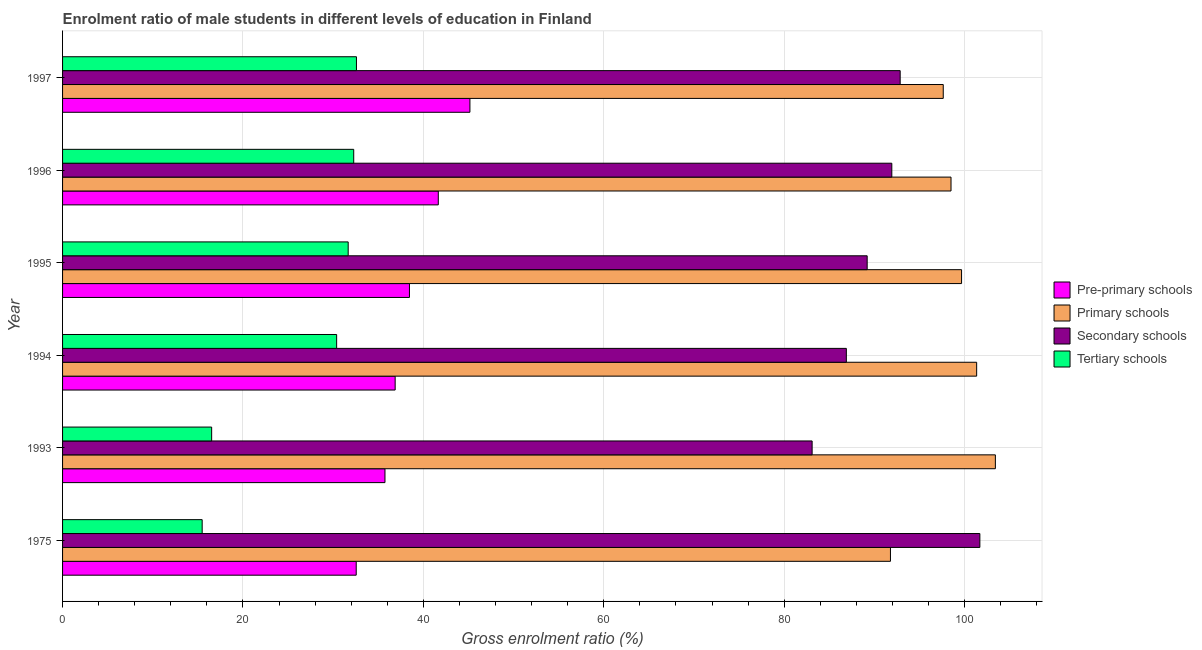How many bars are there on the 2nd tick from the top?
Your answer should be very brief. 4. What is the gross enrolment ratio(female) in tertiary schools in 1994?
Ensure brevity in your answer.  30.38. Across all years, what is the maximum gross enrolment ratio(female) in pre-primary schools?
Provide a short and direct response. 45.16. Across all years, what is the minimum gross enrolment ratio(female) in primary schools?
Keep it short and to the point. 91.78. In which year was the gross enrolment ratio(female) in secondary schools maximum?
Give a very brief answer. 1975. In which year was the gross enrolment ratio(female) in primary schools minimum?
Your response must be concise. 1975. What is the total gross enrolment ratio(female) in secondary schools in the graph?
Your response must be concise. 545.68. What is the difference between the gross enrolment ratio(female) in pre-primary schools in 1993 and that in 1997?
Your answer should be compact. -9.42. What is the difference between the gross enrolment ratio(female) in primary schools in 1993 and the gross enrolment ratio(female) in pre-primary schools in 1975?
Offer a very short reply. 70.86. What is the average gross enrolment ratio(female) in tertiary schools per year?
Provide a short and direct response. 26.49. In the year 1997, what is the difference between the gross enrolment ratio(female) in secondary schools and gross enrolment ratio(female) in tertiary schools?
Provide a short and direct response. 60.28. In how many years, is the gross enrolment ratio(female) in pre-primary schools greater than 60 %?
Your answer should be very brief. 0. What is the ratio of the gross enrolment ratio(female) in pre-primary schools in 1993 to that in 1996?
Provide a short and direct response. 0.86. Is the gross enrolment ratio(female) in secondary schools in 1975 less than that in 1994?
Ensure brevity in your answer.  No. Is the difference between the gross enrolment ratio(female) in pre-primary schools in 1993 and 1994 greater than the difference between the gross enrolment ratio(female) in secondary schools in 1993 and 1994?
Provide a short and direct response. Yes. What is the difference between the highest and the second highest gross enrolment ratio(female) in pre-primary schools?
Give a very brief answer. 3.51. What is the difference between the highest and the lowest gross enrolment ratio(female) in pre-primary schools?
Keep it short and to the point. 12.61. In how many years, is the gross enrolment ratio(female) in primary schools greater than the average gross enrolment ratio(female) in primary schools taken over all years?
Keep it short and to the point. 3. What does the 4th bar from the top in 1993 represents?
Give a very brief answer. Pre-primary schools. What does the 1st bar from the bottom in 1996 represents?
Offer a terse response. Pre-primary schools. How many years are there in the graph?
Your answer should be compact. 6. What is the difference between two consecutive major ticks on the X-axis?
Your response must be concise. 20. Are the values on the major ticks of X-axis written in scientific E-notation?
Provide a succinct answer. No. How many legend labels are there?
Provide a succinct answer. 4. What is the title of the graph?
Your answer should be compact. Enrolment ratio of male students in different levels of education in Finland. What is the label or title of the Y-axis?
Keep it short and to the point. Year. What is the Gross enrolment ratio (%) of Pre-primary schools in 1975?
Offer a terse response. 32.56. What is the Gross enrolment ratio (%) of Primary schools in 1975?
Keep it short and to the point. 91.78. What is the Gross enrolment ratio (%) in Secondary schools in 1975?
Keep it short and to the point. 101.69. What is the Gross enrolment ratio (%) of Tertiary schools in 1975?
Give a very brief answer. 15.48. What is the Gross enrolment ratio (%) in Pre-primary schools in 1993?
Ensure brevity in your answer.  35.74. What is the Gross enrolment ratio (%) in Primary schools in 1993?
Offer a very short reply. 103.41. What is the Gross enrolment ratio (%) of Secondary schools in 1993?
Make the answer very short. 83.1. What is the Gross enrolment ratio (%) in Tertiary schools in 1993?
Make the answer very short. 16.53. What is the Gross enrolment ratio (%) in Pre-primary schools in 1994?
Make the answer very short. 36.87. What is the Gross enrolment ratio (%) of Primary schools in 1994?
Keep it short and to the point. 101.34. What is the Gross enrolment ratio (%) in Secondary schools in 1994?
Your answer should be very brief. 86.89. What is the Gross enrolment ratio (%) of Tertiary schools in 1994?
Provide a succinct answer. 30.38. What is the Gross enrolment ratio (%) in Pre-primary schools in 1995?
Provide a succinct answer. 38.46. What is the Gross enrolment ratio (%) in Primary schools in 1995?
Your answer should be compact. 99.67. What is the Gross enrolment ratio (%) of Secondary schools in 1995?
Keep it short and to the point. 89.2. What is the Gross enrolment ratio (%) of Tertiary schools in 1995?
Give a very brief answer. 31.66. What is the Gross enrolment ratio (%) of Pre-primary schools in 1996?
Ensure brevity in your answer.  41.65. What is the Gross enrolment ratio (%) in Primary schools in 1996?
Your response must be concise. 98.5. What is the Gross enrolment ratio (%) in Secondary schools in 1996?
Offer a terse response. 91.93. What is the Gross enrolment ratio (%) of Tertiary schools in 1996?
Your response must be concise. 32.28. What is the Gross enrolment ratio (%) in Pre-primary schools in 1997?
Provide a succinct answer. 45.16. What is the Gross enrolment ratio (%) of Primary schools in 1997?
Your response must be concise. 97.63. What is the Gross enrolment ratio (%) of Secondary schools in 1997?
Offer a very short reply. 92.86. What is the Gross enrolment ratio (%) of Tertiary schools in 1997?
Give a very brief answer. 32.58. Across all years, what is the maximum Gross enrolment ratio (%) of Pre-primary schools?
Your answer should be compact. 45.16. Across all years, what is the maximum Gross enrolment ratio (%) of Primary schools?
Your answer should be compact. 103.41. Across all years, what is the maximum Gross enrolment ratio (%) of Secondary schools?
Make the answer very short. 101.69. Across all years, what is the maximum Gross enrolment ratio (%) of Tertiary schools?
Provide a short and direct response. 32.58. Across all years, what is the minimum Gross enrolment ratio (%) of Pre-primary schools?
Offer a very short reply. 32.56. Across all years, what is the minimum Gross enrolment ratio (%) of Primary schools?
Your response must be concise. 91.78. Across all years, what is the minimum Gross enrolment ratio (%) of Secondary schools?
Keep it short and to the point. 83.1. Across all years, what is the minimum Gross enrolment ratio (%) of Tertiary schools?
Keep it short and to the point. 15.48. What is the total Gross enrolment ratio (%) in Pre-primary schools in the graph?
Offer a very short reply. 230.44. What is the total Gross enrolment ratio (%) of Primary schools in the graph?
Offer a very short reply. 592.33. What is the total Gross enrolment ratio (%) of Secondary schools in the graph?
Your answer should be very brief. 545.68. What is the total Gross enrolment ratio (%) in Tertiary schools in the graph?
Your answer should be compact. 158.91. What is the difference between the Gross enrolment ratio (%) of Pre-primary schools in 1975 and that in 1993?
Your answer should be compact. -3.19. What is the difference between the Gross enrolment ratio (%) of Primary schools in 1975 and that in 1993?
Your answer should be very brief. -11.63. What is the difference between the Gross enrolment ratio (%) of Secondary schools in 1975 and that in 1993?
Provide a short and direct response. 18.59. What is the difference between the Gross enrolment ratio (%) of Tertiary schools in 1975 and that in 1993?
Make the answer very short. -1.05. What is the difference between the Gross enrolment ratio (%) of Pre-primary schools in 1975 and that in 1994?
Your answer should be very brief. -4.32. What is the difference between the Gross enrolment ratio (%) in Primary schools in 1975 and that in 1994?
Your response must be concise. -9.56. What is the difference between the Gross enrolment ratio (%) of Secondary schools in 1975 and that in 1994?
Ensure brevity in your answer.  14.8. What is the difference between the Gross enrolment ratio (%) in Tertiary schools in 1975 and that in 1994?
Make the answer very short. -14.91. What is the difference between the Gross enrolment ratio (%) of Pre-primary schools in 1975 and that in 1995?
Your answer should be very brief. -5.9. What is the difference between the Gross enrolment ratio (%) in Primary schools in 1975 and that in 1995?
Offer a very short reply. -7.88. What is the difference between the Gross enrolment ratio (%) of Secondary schools in 1975 and that in 1995?
Ensure brevity in your answer.  12.49. What is the difference between the Gross enrolment ratio (%) in Tertiary schools in 1975 and that in 1995?
Ensure brevity in your answer.  -16.19. What is the difference between the Gross enrolment ratio (%) of Pre-primary schools in 1975 and that in 1996?
Ensure brevity in your answer.  -9.1. What is the difference between the Gross enrolment ratio (%) in Primary schools in 1975 and that in 1996?
Ensure brevity in your answer.  -6.71. What is the difference between the Gross enrolment ratio (%) in Secondary schools in 1975 and that in 1996?
Keep it short and to the point. 9.76. What is the difference between the Gross enrolment ratio (%) of Tertiary schools in 1975 and that in 1996?
Give a very brief answer. -16.8. What is the difference between the Gross enrolment ratio (%) in Pre-primary schools in 1975 and that in 1997?
Provide a short and direct response. -12.61. What is the difference between the Gross enrolment ratio (%) in Primary schools in 1975 and that in 1997?
Provide a short and direct response. -5.85. What is the difference between the Gross enrolment ratio (%) of Secondary schools in 1975 and that in 1997?
Provide a succinct answer. 8.83. What is the difference between the Gross enrolment ratio (%) of Tertiary schools in 1975 and that in 1997?
Offer a terse response. -17.1. What is the difference between the Gross enrolment ratio (%) in Pre-primary schools in 1993 and that in 1994?
Keep it short and to the point. -1.13. What is the difference between the Gross enrolment ratio (%) in Primary schools in 1993 and that in 1994?
Ensure brevity in your answer.  2.08. What is the difference between the Gross enrolment ratio (%) in Secondary schools in 1993 and that in 1994?
Make the answer very short. -3.79. What is the difference between the Gross enrolment ratio (%) of Tertiary schools in 1993 and that in 1994?
Offer a terse response. -13.86. What is the difference between the Gross enrolment ratio (%) in Pre-primary schools in 1993 and that in 1995?
Your response must be concise. -2.71. What is the difference between the Gross enrolment ratio (%) in Primary schools in 1993 and that in 1995?
Offer a terse response. 3.75. What is the difference between the Gross enrolment ratio (%) in Secondary schools in 1993 and that in 1995?
Keep it short and to the point. -6.1. What is the difference between the Gross enrolment ratio (%) in Tertiary schools in 1993 and that in 1995?
Offer a very short reply. -15.14. What is the difference between the Gross enrolment ratio (%) of Pre-primary schools in 1993 and that in 1996?
Your response must be concise. -5.91. What is the difference between the Gross enrolment ratio (%) in Primary schools in 1993 and that in 1996?
Your answer should be very brief. 4.92. What is the difference between the Gross enrolment ratio (%) of Secondary schools in 1993 and that in 1996?
Offer a very short reply. -8.83. What is the difference between the Gross enrolment ratio (%) of Tertiary schools in 1993 and that in 1996?
Offer a very short reply. -15.75. What is the difference between the Gross enrolment ratio (%) of Pre-primary schools in 1993 and that in 1997?
Your answer should be very brief. -9.42. What is the difference between the Gross enrolment ratio (%) of Primary schools in 1993 and that in 1997?
Provide a succinct answer. 5.78. What is the difference between the Gross enrolment ratio (%) in Secondary schools in 1993 and that in 1997?
Provide a short and direct response. -9.76. What is the difference between the Gross enrolment ratio (%) of Tertiary schools in 1993 and that in 1997?
Your response must be concise. -16.05. What is the difference between the Gross enrolment ratio (%) in Pre-primary schools in 1994 and that in 1995?
Your response must be concise. -1.59. What is the difference between the Gross enrolment ratio (%) in Primary schools in 1994 and that in 1995?
Make the answer very short. 1.67. What is the difference between the Gross enrolment ratio (%) in Secondary schools in 1994 and that in 1995?
Provide a short and direct response. -2.31. What is the difference between the Gross enrolment ratio (%) of Tertiary schools in 1994 and that in 1995?
Your answer should be very brief. -1.28. What is the difference between the Gross enrolment ratio (%) in Pre-primary schools in 1994 and that in 1996?
Offer a very short reply. -4.78. What is the difference between the Gross enrolment ratio (%) of Primary schools in 1994 and that in 1996?
Give a very brief answer. 2.84. What is the difference between the Gross enrolment ratio (%) of Secondary schools in 1994 and that in 1996?
Ensure brevity in your answer.  -5.04. What is the difference between the Gross enrolment ratio (%) of Tertiary schools in 1994 and that in 1996?
Provide a short and direct response. -1.89. What is the difference between the Gross enrolment ratio (%) in Pre-primary schools in 1994 and that in 1997?
Offer a terse response. -8.29. What is the difference between the Gross enrolment ratio (%) in Primary schools in 1994 and that in 1997?
Your answer should be very brief. 3.7. What is the difference between the Gross enrolment ratio (%) of Secondary schools in 1994 and that in 1997?
Offer a very short reply. -5.97. What is the difference between the Gross enrolment ratio (%) in Tertiary schools in 1994 and that in 1997?
Your answer should be very brief. -2.2. What is the difference between the Gross enrolment ratio (%) in Pre-primary schools in 1995 and that in 1996?
Provide a short and direct response. -3.2. What is the difference between the Gross enrolment ratio (%) of Primary schools in 1995 and that in 1996?
Keep it short and to the point. 1.17. What is the difference between the Gross enrolment ratio (%) of Secondary schools in 1995 and that in 1996?
Your answer should be very brief. -2.73. What is the difference between the Gross enrolment ratio (%) in Tertiary schools in 1995 and that in 1996?
Ensure brevity in your answer.  -0.61. What is the difference between the Gross enrolment ratio (%) of Pre-primary schools in 1995 and that in 1997?
Ensure brevity in your answer.  -6.7. What is the difference between the Gross enrolment ratio (%) in Primary schools in 1995 and that in 1997?
Your answer should be compact. 2.03. What is the difference between the Gross enrolment ratio (%) in Secondary schools in 1995 and that in 1997?
Provide a short and direct response. -3.66. What is the difference between the Gross enrolment ratio (%) of Tertiary schools in 1995 and that in 1997?
Keep it short and to the point. -0.92. What is the difference between the Gross enrolment ratio (%) of Pre-primary schools in 1996 and that in 1997?
Make the answer very short. -3.51. What is the difference between the Gross enrolment ratio (%) in Primary schools in 1996 and that in 1997?
Give a very brief answer. 0.86. What is the difference between the Gross enrolment ratio (%) of Secondary schools in 1996 and that in 1997?
Your response must be concise. -0.93. What is the difference between the Gross enrolment ratio (%) of Tertiary schools in 1996 and that in 1997?
Offer a terse response. -0.3. What is the difference between the Gross enrolment ratio (%) of Pre-primary schools in 1975 and the Gross enrolment ratio (%) of Primary schools in 1993?
Provide a succinct answer. -70.86. What is the difference between the Gross enrolment ratio (%) of Pre-primary schools in 1975 and the Gross enrolment ratio (%) of Secondary schools in 1993?
Keep it short and to the point. -50.54. What is the difference between the Gross enrolment ratio (%) of Pre-primary schools in 1975 and the Gross enrolment ratio (%) of Tertiary schools in 1993?
Your answer should be compact. 16.03. What is the difference between the Gross enrolment ratio (%) of Primary schools in 1975 and the Gross enrolment ratio (%) of Secondary schools in 1993?
Provide a short and direct response. 8.68. What is the difference between the Gross enrolment ratio (%) of Primary schools in 1975 and the Gross enrolment ratio (%) of Tertiary schools in 1993?
Keep it short and to the point. 75.25. What is the difference between the Gross enrolment ratio (%) of Secondary schools in 1975 and the Gross enrolment ratio (%) of Tertiary schools in 1993?
Give a very brief answer. 85.16. What is the difference between the Gross enrolment ratio (%) in Pre-primary schools in 1975 and the Gross enrolment ratio (%) in Primary schools in 1994?
Provide a short and direct response. -68.78. What is the difference between the Gross enrolment ratio (%) of Pre-primary schools in 1975 and the Gross enrolment ratio (%) of Secondary schools in 1994?
Offer a very short reply. -54.34. What is the difference between the Gross enrolment ratio (%) of Pre-primary schools in 1975 and the Gross enrolment ratio (%) of Tertiary schools in 1994?
Offer a terse response. 2.17. What is the difference between the Gross enrolment ratio (%) of Primary schools in 1975 and the Gross enrolment ratio (%) of Secondary schools in 1994?
Offer a very short reply. 4.89. What is the difference between the Gross enrolment ratio (%) in Primary schools in 1975 and the Gross enrolment ratio (%) in Tertiary schools in 1994?
Keep it short and to the point. 61.4. What is the difference between the Gross enrolment ratio (%) in Secondary schools in 1975 and the Gross enrolment ratio (%) in Tertiary schools in 1994?
Provide a succinct answer. 71.31. What is the difference between the Gross enrolment ratio (%) of Pre-primary schools in 1975 and the Gross enrolment ratio (%) of Primary schools in 1995?
Provide a succinct answer. -67.11. What is the difference between the Gross enrolment ratio (%) in Pre-primary schools in 1975 and the Gross enrolment ratio (%) in Secondary schools in 1995?
Your answer should be very brief. -56.64. What is the difference between the Gross enrolment ratio (%) in Pre-primary schools in 1975 and the Gross enrolment ratio (%) in Tertiary schools in 1995?
Ensure brevity in your answer.  0.89. What is the difference between the Gross enrolment ratio (%) of Primary schools in 1975 and the Gross enrolment ratio (%) of Secondary schools in 1995?
Make the answer very short. 2.58. What is the difference between the Gross enrolment ratio (%) of Primary schools in 1975 and the Gross enrolment ratio (%) of Tertiary schools in 1995?
Provide a short and direct response. 60.12. What is the difference between the Gross enrolment ratio (%) in Secondary schools in 1975 and the Gross enrolment ratio (%) in Tertiary schools in 1995?
Provide a short and direct response. 70.03. What is the difference between the Gross enrolment ratio (%) of Pre-primary schools in 1975 and the Gross enrolment ratio (%) of Primary schools in 1996?
Your answer should be compact. -65.94. What is the difference between the Gross enrolment ratio (%) of Pre-primary schools in 1975 and the Gross enrolment ratio (%) of Secondary schools in 1996?
Provide a short and direct response. -59.38. What is the difference between the Gross enrolment ratio (%) in Pre-primary schools in 1975 and the Gross enrolment ratio (%) in Tertiary schools in 1996?
Your response must be concise. 0.28. What is the difference between the Gross enrolment ratio (%) of Primary schools in 1975 and the Gross enrolment ratio (%) of Secondary schools in 1996?
Your answer should be very brief. -0.15. What is the difference between the Gross enrolment ratio (%) of Primary schools in 1975 and the Gross enrolment ratio (%) of Tertiary schools in 1996?
Provide a short and direct response. 59.5. What is the difference between the Gross enrolment ratio (%) in Secondary schools in 1975 and the Gross enrolment ratio (%) in Tertiary schools in 1996?
Make the answer very short. 69.41. What is the difference between the Gross enrolment ratio (%) in Pre-primary schools in 1975 and the Gross enrolment ratio (%) in Primary schools in 1997?
Offer a very short reply. -65.08. What is the difference between the Gross enrolment ratio (%) in Pre-primary schools in 1975 and the Gross enrolment ratio (%) in Secondary schools in 1997?
Give a very brief answer. -60.3. What is the difference between the Gross enrolment ratio (%) in Pre-primary schools in 1975 and the Gross enrolment ratio (%) in Tertiary schools in 1997?
Offer a terse response. -0.03. What is the difference between the Gross enrolment ratio (%) of Primary schools in 1975 and the Gross enrolment ratio (%) of Secondary schools in 1997?
Provide a succinct answer. -1.08. What is the difference between the Gross enrolment ratio (%) in Primary schools in 1975 and the Gross enrolment ratio (%) in Tertiary schools in 1997?
Make the answer very short. 59.2. What is the difference between the Gross enrolment ratio (%) in Secondary schools in 1975 and the Gross enrolment ratio (%) in Tertiary schools in 1997?
Offer a terse response. 69.11. What is the difference between the Gross enrolment ratio (%) of Pre-primary schools in 1993 and the Gross enrolment ratio (%) of Primary schools in 1994?
Give a very brief answer. -65.6. What is the difference between the Gross enrolment ratio (%) of Pre-primary schools in 1993 and the Gross enrolment ratio (%) of Secondary schools in 1994?
Provide a short and direct response. -51.15. What is the difference between the Gross enrolment ratio (%) of Pre-primary schools in 1993 and the Gross enrolment ratio (%) of Tertiary schools in 1994?
Keep it short and to the point. 5.36. What is the difference between the Gross enrolment ratio (%) in Primary schools in 1993 and the Gross enrolment ratio (%) in Secondary schools in 1994?
Offer a very short reply. 16.52. What is the difference between the Gross enrolment ratio (%) of Primary schools in 1993 and the Gross enrolment ratio (%) of Tertiary schools in 1994?
Provide a short and direct response. 73.03. What is the difference between the Gross enrolment ratio (%) of Secondary schools in 1993 and the Gross enrolment ratio (%) of Tertiary schools in 1994?
Make the answer very short. 52.71. What is the difference between the Gross enrolment ratio (%) of Pre-primary schools in 1993 and the Gross enrolment ratio (%) of Primary schools in 1995?
Provide a short and direct response. -63.92. What is the difference between the Gross enrolment ratio (%) of Pre-primary schools in 1993 and the Gross enrolment ratio (%) of Secondary schools in 1995?
Provide a succinct answer. -53.46. What is the difference between the Gross enrolment ratio (%) in Pre-primary schools in 1993 and the Gross enrolment ratio (%) in Tertiary schools in 1995?
Ensure brevity in your answer.  4.08. What is the difference between the Gross enrolment ratio (%) of Primary schools in 1993 and the Gross enrolment ratio (%) of Secondary schools in 1995?
Ensure brevity in your answer.  14.21. What is the difference between the Gross enrolment ratio (%) of Primary schools in 1993 and the Gross enrolment ratio (%) of Tertiary schools in 1995?
Your answer should be very brief. 71.75. What is the difference between the Gross enrolment ratio (%) in Secondary schools in 1993 and the Gross enrolment ratio (%) in Tertiary schools in 1995?
Provide a succinct answer. 51.43. What is the difference between the Gross enrolment ratio (%) in Pre-primary schools in 1993 and the Gross enrolment ratio (%) in Primary schools in 1996?
Your answer should be compact. -62.75. What is the difference between the Gross enrolment ratio (%) in Pre-primary schools in 1993 and the Gross enrolment ratio (%) in Secondary schools in 1996?
Your answer should be compact. -56.19. What is the difference between the Gross enrolment ratio (%) in Pre-primary schools in 1993 and the Gross enrolment ratio (%) in Tertiary schools in 1996?
Offer a very short reply. 3.46. What is the difference between the Gross enrolment ratio (%) in Primary schools in 1993 and the Gross enrolment ratio (%) in Secondary schools in 1996?
Keep it short and to the point. 11.48. What is the difference between the Gross enrolment ratio (%) of Primary schools in 1993 and the Gross enrolment ratio (%) of Tertiary schools in 1996?
Offer a very short reply. 71.14. What is the difference between the Gross enrolment ratio (%) of Secondary schools in 1993 and the Gross enrolment ratio (%) of Tertiary schools in 1996?
Offer a terse response. 50.82. What is the difference between the Gross enrolment ratio (%) in Pre-primary schools in 1993 and the Gross enrolment ratio (%) in Primary schools in 1997?
Make the answer very short. -61.89. What is the difference between the Gross enrolment ratio (%) of Pre-primary schools in 1993 and the Gross enrolment ratio (%) of Secondary schools in 1997?
Provide a short and direct response. -57.12. What is the difference between the Gross enrolment ratio (%) in Pre-primary schools in 1993 and the Gross enrolment ratio (%) in Tertiary schools in 1997?
Provide a short and direct response. 3.16. What is the difference between the Gross enrolment ratio (%) in Primary schools in 1993 and the Gross enrolment ratio (%) in Secondary schools in 1997?
Provide a succinct answer. 10.55. What is the difference between the Gross enrolment ratio (%) in Primary schools in 1993 and the Gross enrolment ratio (%) in Tertiary schools in 1997?
Your answer should be compact. 70.83. What is the difference between the Gross enrolment ratio (%) in Secondary schools in 1993 and the Gross enrolment ratio (%) in Tertiary schools in 1997?
Make the answer very short. 50.52. What is the difference between the Gross enrolment ratio (%) in Pre-primary schools in 1994 and the Gross enrolment ratio (%) in Primary schools in 1995?
Give a very brief answer. -62.79. What is the difference between the Gross enrolment ratio (%) in Pre-primary schools in 1994 and the Gross enrolment ratio (%) in Secondary schools in 1995?
Your answer should be compact. -52.33. What is the difference between the Gross enrolment ratio (%) of Pre-primary schools in 1994 and the Gross enrolment ratio (%) of Tertiary schools in 1995?
Provide a succinct answer. 5.21. What is the difference between the Gross enrolment ratio (%) in Primary schools in 1994 and the Gross enrolment ratio (%) in Secondary schools in 1995?
Provide a succinct answer. 12.14. What is the difference between the Gross enrolment ratio (%) in Primary schools in 1994 and the Gross enrolment ratio (%) in Tertiary schools in 1995?
Ensure brevity in your answer.  69.67. What is the difference between the Gross enrolment ratio (%) of Secondary schools in 1994 and the Gross enrolment ratio (%) of Tertiary schools in 1995?
Make the answer very short. 55.23. What is the difference between the Gross enrolment ratio (%) of Pre-primary schools in 1994 and the Gross enrolment ratio (%) of Primary schools in 1996?
Ensure brevity in your answer.  -61.62. What is the difference between the Gross enrolment ratio (%) of Pre-primary schools in 1994 and the Gross enrolment ratio (%) of Secondary schools in 1996?
Your response must be concise. -55.06. What is the difference between the Gross enrolment ratio (%) in Pre-primary schools in 1994 and the Gross enrolment ratio (%) in Tertiary schools in 1996?
Offer a terse response. 4.59. What is the difference between the Gross enrolment ratio (%) of Primary schools in 1994 and the Gross enrolment ratio (%) of Secondary schools in 1996?
Offer a terse response. 9.41. What is the difference between the Gross enrolment ratio (%) of Primary schools in 1994 and the Gross enrolment ratio (%) of Tertiary schools in 1996?
Keep it short and to the point. 69.06. What is the difference between the Gross enrolment ratio (%) in Secondary schools in 1994 and the Gross enrolment ratio (%) in Tertiary schools in 1996?
Ensure brevity in your answer.  54.61. What is the difference between the Gross enrolment ratio (%) of Pre-primary schools in 1994 and the Gross enrolment ratio (%) of Primary schools in 1997?
Offer a very short reply. -60.76. What is the difference between the Gross enrolment ratio (%) of Pre-primary schools in 1994 and the Gross enrolment ratio (%) of Secondary schools in 1997?
Your response must be concise. -55.99. What is the difference between the Gross enrolment ratio (%) in Pre-primary schools in 1994 and the Gross enrolment ratio (%) in Tertiary schools in 1997?
Offer a terse response. 4.29. What is the difference between the Gross enrolment ratio (%) in Primary schools in 1994 and the Gross enrolment ratio (%) in Secondary schools in 1997?
Your answer should be compact. 8.48. What is the difference between the Gross enrolment ratio (%) of Primary schools in 1994 and the Gross enrolment ratio (%) of Tertiary schools in 1997?
Ensure brevity in your answer.  68.76. What is the difference between the Gross enrolment ratio (%) in Secondary schools in 1994 and the Gross enrolment ratio (%) in Tertiary schools in 1997?
Make the answer very short. 54.31. What is the difference between the Gross enrolment ratio (%) in Pre-primary schools in 1995 and the Gross enrolment ratio (%) in Primary schools in 1996?
Keep it short and to the point. -60.04. What is the difference between the Gross enrolment ratio (%) in Pre-primary schools in 1995 and the Gross enrolment ratio (%) in Secondary schools in 1996?
Make the answer very short. -53.48. What is the difference between the Gross enrolment ratio (%) of Pre-primary schools in 1995 and the Gross enrolment ratio (%) of Tertiary schools in 1996?
Provide a succinct answer. 6.18. What is the difference between the Gross enrolment ratio (%) of Primary schools in 1995 and the Gross enrolment ratio (%) of Secondary schools in 1996?
Give a very brief answer. 7.73. What is the difference between the Gross enrolment ratio (%) of Primary schools in 1995 and the Gross enrolment ratio (%) of Tertiary schools in 1996?
Give a very brief answer. 67.39. What is the difference between the Gross enrolment ratio (%) in Secondary schools in 1995 and the Gross enrolment ratio (%) in Tertiary schools in 1996?
Provide a short and direct response. 56.92. What is the difference between the Gross enrolment ratio (%) of Pre-primary schools in 1995 and the Gross enrolment ratio (%) of Primary schools in 1997?
Your answer should be compact. -59.18. What is the difference between the Gross enrolment ratio (%) of Pre-primary schools in 1995 and the Gross enrolment ratio (%) of Secondary schools in 1997?
Your answer should be compact. -54.4. What is the difference between the Gross enrolment ratio (%) in Pre-primary schools in 1995 and the Gross enrolment ratio (%) in Tertiary schools in 1997?
Your answer should be compact. 5.88. What is the difference between the Gross enrolment ratio (%) of Primary schools in 1995 and the Gross enrolment ratio (%) of Secondary schools in 1997?
Your response must be concise. 6.81. What is the difference between the Gross enrolment ratio (%) of Primary schools in 1995 and the Gross enrolment ratio (%) of Tertiary schools in 1997?
Give a very brief answer. 67.08. What is the difference between the Gross enrolment ratio (%) in Secondary schools in 1995 and the Gross enrolment ratio (%) in Tertiary schools in 1997?
Offer a very short reply. 56.62. What is the difference between the Gross enrolment ratio (%) of Pre-primary schools in 1996 and the Gross enrolment ratio (%) of Primary schools in 1997?
Your response must be concise. -55.98. What is the difference between the Gross enrolment ratio (%) of Pre-primary schools in 1996 and the Gross enrolment ratio (%) of Secondary schools in 1997?
Your response must be concise. -51.21. What is the difference between the Gross enrolment ratio (%) in Pre-primary schools in 1996 and the Gross enrolment ratio (%) in Tertiary schools in 1997?
Offer a very short reply. 9.07. What is the difference between the Gross enrolment ratio (%) of Primary schools in 1996 and the Gross enrolment ratio (%) of Secondary schools in 1997?
Give a very brief answer. 5.64. What is the difference between the Gross enrolment ratio (%) in Primary schools in 1996 and the Gross enrolment ratio (%) in Tertiary schools in 1997?
Your answer should be compact. 65.92. What is the difference between the Gross enrolment ratio (%) in Secondary schools in 1996 and the Gross enrolment ratio (%) in Tertiary schools in 1997?
Ensure brevity in your answer.  59.35. What is the average Gross enrolment ratio (%) of Pre-primary schools per year?
Offer a very short reply. 38.41. What is the average Gross enrolment ratio (%) in Primary schools per year?
Keep it short and to the point. 98.72. What is the average Gross enrolment ratio (%) in Secondary schools per year?
Give a very brief answer. 90.95. What is the average Gross enrolment ratio (%) in Tertiary schools per year?
Give a very brief answer. 26.49. In the year 1975, what is the difference between the Gross enrolment ratio (%) of Pre-primary schools and Gross enrolment ratio (%) of Primary schools?
Your response must be concise. -59.23. In the year 1975, what is the difference between the Gross enrolment ratio (%) in Pre-primary schools and Gross enrolment ratio (%) in Secondary schools?
Your answer should be compact. -69.14. In the year 1975, what is the difference between the Gross enrolment ratio (%) of Pre-primary schools and Gross enrolment ratio (%) of Tertiary schools?
Keep it short and to the point. 17.08. In the year 1975, what is the difference between the Gross enrolment ratio (%) of Primary schools and Gross enrolment ratio (%) of Secondary schools?
Give a very brief answer. -9.91. In the year 1975, what is the difference between the Gross enrolment ratio (%) of Primary schools and Gross enrolment ratio (%) of Tertiary schools?
Provide a succinct answer. 76.3. In the year 1975, what is the difference between the Gross enrolment ratio (%) in Secondary schools and Gross enrolment ratio (%) in Tertiary schools?
Provide a succinct answer. 86.22. In the year 1993, what is the difference between the Gross enrolment ratio (%) in Pre-primary schools and Gross enrolment ratio (%) in Primary schools?
Your answer should be compact. -67.67. In the year 1993, what is the difference between the Gross enrolment ratio (%) of Pre-primary schools and Gross enrolment ratio (%) of Secondary schools?
Keep it short and to the point. -47.36. In the year 1993, what is the difference between the Gross enrolment ratio (%) of Pre-primary schools and Gross enrolment ratio (%) of Tertiary schools?
Give a very brief answer. 19.21. In the year 1993, what is the difference between the Gross enrolment ratio (%) in Primary schools and Gross enrolment ratio (%) in Secondary schools?
Provide a succinct answer. 20.32. In the year 1993, what is the difference between the Gross enrolment ratio (%) of Primary schools and Gross enrolment ratio (%) of Tertiary schools?
Offer a terse response. 86.89. In the year 1993, what is the difference between the Gross enrolment ratio (%) of Secondary schools and Gross enrolment ratio (%) of Tertiary schools?
Offer a terse response. 66.57. In the year 1994, what is the difference between the Gross enrolment ratio (%) in Pre-primary schools and Gross enrolment ratio (%) in Primary schools?
Give a very brief answer. -64.47. In the year 1994, what is the difference between the Gross enrolment ratio (%) in Pre-primary schools and Gross enrolment ratio (%) in Secondary schools?
Ensure brevity in your answer.  -50.02. In the year 1994, what is the difference between the Gross enrolment ratio (%) in Pre-primary schools and Gross enrolment ratio (%) in Tertiary schools?
Your response must be concise. 6.49. In the year 1994, what is the difference between the Gross enrolment ratio (%) of Primary schools and Gross enrolment ratio (%) of Secondary schools?
Your answer should be compact. 14.45. In the year 1994, what is the difference between the Gross enrolment ratio (%) in Primary schools and Gross enrolment ratio (%) in Tertiary schools?
Ensure brevity in your answer.  70.95. In the year 1994, what is the difference between the Gross enrolment ratio (%) in Secondary schools and Gross enrolment ratio (%) in Tertiary schools?
Provide a succinct answer. 56.51. In the year 1995, what is the difference between the Gross enrolment ratio (%) of Pre-primary schools and Gross enrolment ratio (%) of Primary schools?
Give a very brief answer. -61.21. In the year 1995, what is the difference between the Gross enrolment ratio (%) of Pre-primary schools and Gross enrolment ratio (%) of Secondary schools?
Your response must be concise. -50.74. In the year 1995, what is the difference between the Gross enrolment ratio (%) in Pre-primary schools and Gross enrolment ratio (%) in Tertiary schools?
Offer a very short reply. 6.79. In the year 1995, what is the difference between the Gross enrolment ratio (%) in Primary schools and Gross enrolment ratio (%) in Secondary schools?
Your answer should be compact. 10.46. In the year 1995, what is the difference between the Gross enrolment ratio (%) of Primary schools and Gross enrolment ratio (%) of Tertiary schools?
Keep it short and to the point. 68. In the year 1995, what is the difference between the Gross enrolment ratio (%) of Secondary schools and Gross enrolment ratio (%) of Tertiary schools?
Ensure brevity in your answer.  57.54. In the year 1996, what is the difference between the Gross enrolment ratio (%) of Pre-primary schools and Gross enrolment ratio (%) of Primary schools?
Give a very brief answer. -56.84. In the year 1996, what is the difference between the Gross enrolment ratio (%) in Pre-primary schools and Gross enrolment ratio (%) in Secondary schools?
Ensure brevity in your answer.  -50.28. In the year 1996, what is the difference between the Gross enrolment ratio (%) in Pre-primary schools and Gross enrolment ratio (%) in Tertiary schools?
Your response must be concise. 9.38. In the year 1996, what is the difference between the Gross enrolment ratio (%) of Primary schools and Gross enrolment ratio (%) of Secondary schools?
Your response must be concise. 6.56. In the year 1996, what is the difference between the Gross enrolment ratio (%) in Primary schools and Gross enrolment ratio (%) in Tertiary schools?
Make the answer very short. 66.22. In the year 1996, what is the difference between the Gross enrolment ratio (%) in Secondary schools and Gross enrolment ratio (%) in Tertiary schools?
Give a very brief answer. 59.65. In the year 1997, what is the difference between the Gross enrolment ratio (%) in Pre-primary schools and Gross enrolment ratio (%) in Primary schools?
Make the answer very short. -52.47. In the year 1997, what is the difference between the Gross enrolment ratio (%) of Pre-primary schools and Gross enrolment ratio (%) of Secondary schools?
Your response must be concise. -47.7. In the year 1997, what is the difference between the Gross enrolment ratio (%) in Pre-primary schools and Gross enrolment ratio (%) in Tertiary schools?
Keep it short and to the point. 12.58. In the year 1997, what is the difference between the Gross enrolment ratio (%) in Primary schools and Gross enrolment ratio (%) in Secondary schools?
Offer a very short reply. 4.77. In the year 1997, what is the difference between the Gross enrolment ratio (%) in Primary schools and Gross enrolment ratio (%) in Tertiary schools?
Provide a succinct answer. 65.05. In the year 1997, what is the difference between the Gross enrolment ratio (%) in Secondary schools and Gross enrolment ratio (%) in Tertiary schools?
Give a very brief answer. 60.28. What is the ratio of the Gross enrolment ratio (%) in Pre-primary schools in 1975 to that in 1993?
Your answer should be very brief. 0.91. What is the ratio of the Gross enrolment ratio (%) in Primary schools in 1975 to that in 1993?
Keep it short and to the point. 0.89. What is the ratio of the Gross enrolment ratio (%) of Secondary schools in 1975 to that in 1993?
Your answer should be compact. 1.22. What is the ratio of the Gross enrolment ratio (%) in Tertiary schools in 1975 to that in 1993?
Keep it short and to the point. 0.94. What is the ratio of the Gross enrolment ratio (%) of Pre-primary schools in 1975 to that in 1994?
Make the answer very short. 0.88. What is the ratio of the Gross enrolment ratio (%) of Primary schools in 1975 to that in 1994?
Offer a terse response. 0.91. What is the ratio of the Gross enrolment ratio (%) of Secondary schools in 1975 to that in 1994?
Your response must be concise. 1.17. What is the ratio of the Gross enrolment ratio (%) of Tertiary schools in 1975 to that in 1994?
Your answer should be compact. 0.51. What is the ratio of the Gross enrolment ratio (%) in Pre-primary schools in 1975 to that in 1995?
Your response must be concise. 0.85. What is the ratio of the Gross enrolment ratio (%) in Primary schools in 1975 to that in 1995?
Your answer should be very brief. 0.92. What is the ratio of the Gross enrolment ratio (%) in Secondary schools in 1975 to that in 1995?
Offer a very short reply. 1.14. What is the ratio of the Gross enrolment ratio (%) in Tertiary schools in 1975 to that in 1995?
Your response must be concise. 0.49. What is the ratio of the Gross enrolment ratio (%) in Pre-primary schools in 1975 to that in 1996?
Give a very brief answer. 0.78. What is the ratio of the Gross enrolment ratio (%) of Primary schools in 1975 to that in 1996?
Give a very brief answer. 0.93. What is the ratio of the Gross enrolment ratio (%) of Secondary schools in 1975 to that in 1996?
Provide a short and direct response. 1.11. What is the ratio of the Gross enrolment ratio (%) in Tertiary schools in 1975 to that in 1996?
Offer a terse response. 0.48. What is the ratio of the Gross enrolment ratio (%) in Pre-primary schools in 1975 to that in 1997?
Ensure brevity in your answer.  0.72. What is the ratio of the Gross enrolment ratio (%) of Primary schools in 1975 to that in 1997?
Offer a very short reply. 0.94. What is the ratio of the Gross enrolment ratio (%) in Secondary schools in 1975 to that in 1997?
Your answer should be compact. 1.1. What is the ratio of the Gross enrolment ratio (%) of Tertiary schools in 1975 to that in 1997?
Ensure brevity in your answer.  0.48. What is the ratio of the Gross enrolment ratio (%) of Pre-primary schools in 1993 to that in 1994?
Your answer should be compact. 0.97. What is the ratio of the Gross enrolment ratio (%) in Primary schools in 1993 to that in 1994?
Offer a terse response. 1.02. What is the ratio of the Gross enrolment ratio (%) in Secondary schools in 1993 to that in 1994?
Make the answer very short. 0.96. What is the ratio of the Gross enrolment ratio (%) in Tertiary schools in 1993 to that in 1994?
Provide a short and direct response. 0.54. What is the ratio of the Gross enrolment ratio (%) of Pre-primary schools in 1993 to that in 1995?
Make the answer very short. 0.93. What is the ratio of the Gross enrolment ratio (%) in Primary schools in 1993 to that in 1995?
Your response must be concise. 1.04. What is the ratio of the Gross enrolment ratio (%) of Secondary schools in 1993 to that in 1995?
Provide a short and direct response. 0.93. What is the ratio of the Gross enrolment ratio (%) of Tertiary schools in 1993 to that in 1995?
Your answer should be very brief. 0.52. What is the ratio of the Gross enrolment ratio (%) of Pre-primary schools in 1993 to that in 1996?
Your response must be concise. 0.86. What is the ratio of the Gross enrolment ratio (%) of Primary schools in 1993 to that in 1996?
Your answer should be compact. 1.05. What is the ratio of the Gross enrolment ratio (%) of Secondary schools in 1993 to that in 1996?
Keep it short and to the point. 0.9. What is the ratio of the Gross enrolment ratio (%) of Tertiary schools in 1993 to that in 1996?
Offer a terse response. 0.51. What is the ratio of the Gross enrolment ratio (%) of Pre-primary schools in 1993 to that in 1997?
Your response must be concise. 0.79. What is the ratio of the Gross enrolment ratio (%) of Primary schools in 1993 to that in 1997?
Your answer should be very brief. 1.06. What is the ratio of the Gross enrolment ratio (%) of Secondary schools in 1993 to that in 1997?
Offer a very short reply. 0.89. What is the ratio of the Gross enrolment ratio (%) of Tertiary schools in 1993 to that in 1997?
Provide a short and direct response. 0.51. What is the ratio of the Gross enrolment ratio (%) in Pre-primary schools in 1994 to that in 1995?
Offer a terse response. 0.96. What is the ratio of the Gross enrolment ratio (%) in Primary schools in 1994 to that in 1995?
Offer a very short reply. 1.02. What is the ratio of the Gross enrolment ratio (%) in Secondary schools in 1994 to that in 1995?
Provide a succinct answer. 0.97. What is the ratio of the Gross enrolment ratio (%) of Tertiary schools in 1994 to that in 1995?
Give a very brief answer. 0.96. What is the ratio of the Gross enrolment ratio (%) of Pre-primary schools in 1994 to that in 1996?
Keep it short and to the point. 0.89. What is the ratio of the Gross enrolment ratio (%) of Primary schools in 1994 to that in 1996?
Give a very brief answer. 1.03. What is the ratio of the Gross enrolment ratio (%) in Secondary schools in 1994 to that in 1996?
Your response must be concise. 0.95. What is the ratio of the Gross enrolment ratio (%) of Tertiary schools in 1994 to that in 1996?
Provide a short and direct response. 0.94. What is the ratio of the Gross enrolment ratio (%) of Pre-primary schools in 1994 to that in 1997?
Give a very brief answer. 0.82. What is the ratio of the Gross enrolment ratio (%) in Primary schools in 1994 to that in 1997?
Make the answer very short. 1.04. What is the ratio of the Gross enrolment ratio (%) in Secondary schools in 1994 to that in 1997?
Your answer should be compact. 0.94. What is the ratio of the Gross enrolment ratio (%) in Tertiary schools in 1994 to that in 1997?
Make the answer very short. 0.93. What is the ratio of the Gross enrolment ratio (%) in Pre-primary schools in 1995 to that in 1996?
Offer a terse response. 0.92. What is the ratio of the Gross enrolment ratio (%) of Primary schools in 1995 to that in 1996?
Ensure brevity in your answer.  1.01. What is the ratio of the Gross enrolment ratio (%) in Secondary schools in 1995 to that in 1996?
Make the answer very short. 0.97. What is the ratio of the Gross enrolment ratio (%) of Pre-primary schools in 1995 to that in 1997?
Your answer should be very brief. 0.85. What is the ratio of the Gross enrolment ratio (%) in Primary schools in 1995 to that in 1997?
Your answer should be compact. 1.02. What is the ratio of the Gross enrolment ratio (%) of Secondary schools in 1995 to that in 1997?
Provide a succinct answer. 0.96. What is the ratio of the Gross enrolment ratio (%) in Tertiary schools in 1995 to that in 1997?
Offer a very short reply. 0.97. What is the ratio of the Gross enrolment ratio (%) of Pre-primary schools in 1996 to that in 1997?
Give a very brief answer. 0.92. What is the ratio of the Gross enrolment ratio (%) in Primary schools in 1996 to that in 1997?
Your response must be concise. 1.01. What is the ratio of the Gross enrolment ratio (%) in Tertiary schools in 1996 to that in 1997?
Your answer should be very brief. 0.99. What is the difference between the highest and the second highest Gross enrolment ratio (%) in Pre-primary schools?
Offer a very short reply. 3.51. What is the difference between the highest and the second highest Gross enrolment ratio (%) in Primary schools?
Offer a terse response. 2.08. What is the difference between the highest and the second highest Gross enrolment ratio (%) of Secondary schools?
Provide a short and direct response. 8.83. What is the difference between the highest and the second highest Gross enrolment ratio (%) in Tertiary schools?
Keep it short and to the point. 0.3. What is the difference between the highest and the lowest Gross enrolment ratio (%) in Pre-primary schools?
Your answer should be very brief. 12.61. What is the difference between the highest and the lowest Gross enrolment ratio (%) of Primary schools?
Keep it short and to the point. 11.63. What is the difference between the highest and the lowest Gross enrolment ratio (%) of Secondary schools?
Keep it short and to the point. 18.59. What is the difference between the highest and the lowest Gross enrolment ratio (%) of Tertiary schools?
Ensure brevity in your answer.  17.1. 